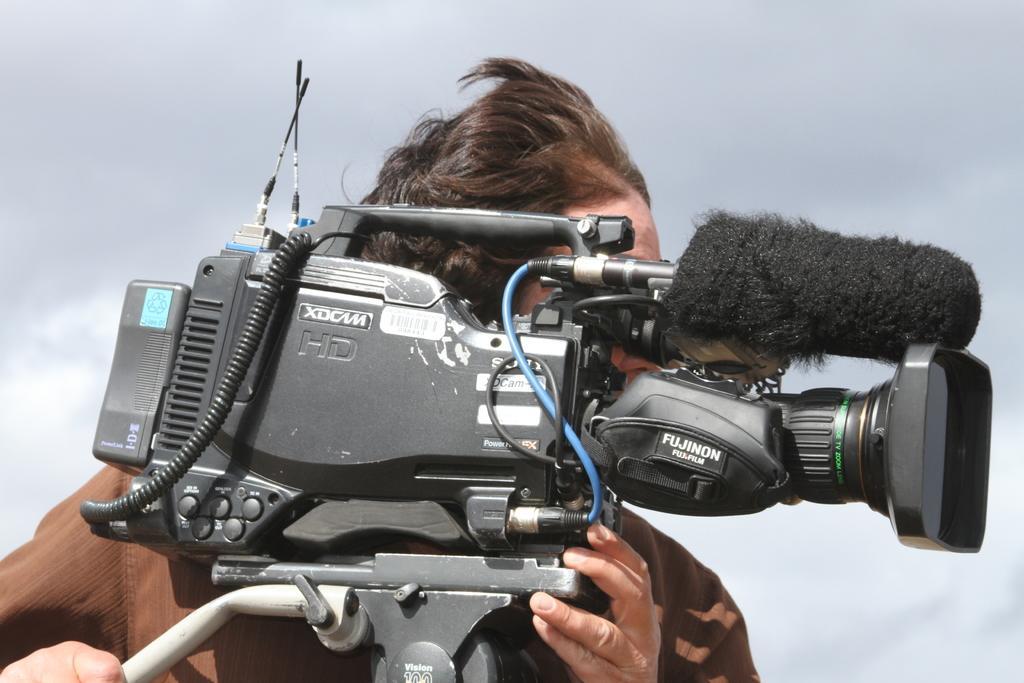Can you describe this image briefly? In this image I can see the person with the brown color dress and the person is holding the camera. I can see the ash color background. 